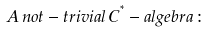Convert formula to latex. <formula><loc_0><loc_0><loc_500><loc_500>A \, n o t - t r i v i a l \, C ^ { ^ { * } } - a l g e b r a \, \colon \,</formula> 